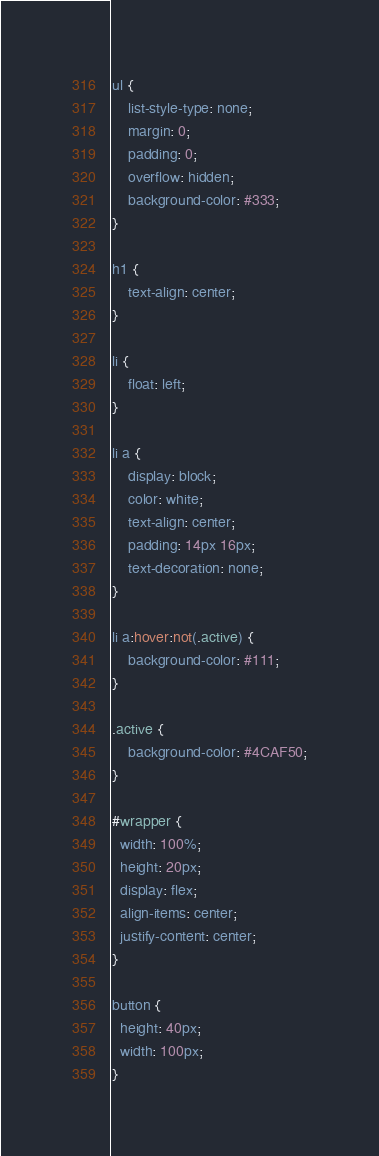<code> <loc_0><loc_0><loc_500><loc_500><_CSS_>ul {
    list-style-type: none;
    margin: 0;
    padding: 0;
    overflow: hidden;
    background-color: #333;
}

h1 {
    text-align: center;
}

li {
    float: left;
}

li a {
    display: block;
    color: white;
    text-align: center;
    padding: 14px 16px;
    text-decoration: none;
}

li a:hover:not(.active) {
    background-color: #111;
}

.active {
    background-color: #4CAF50;
}

#wrapper {
  width: 100%;
  height: 20px;
  display: flex;
  align-items: center;
  justify-content: center;
}

button {
  height: 40px;
  width: 100px;
}
</code> 